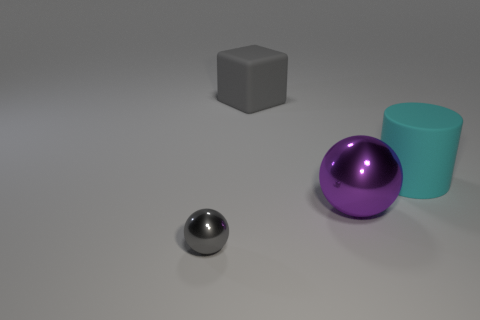Is there anything else that is the same size as the gray ball?
Offer a terse response. No. Does the large object that is left of the purple shiny object have the same color as the small ball?
Provide a succinct answer. Yes. There is a rubber thing that is the same color as the small metallic thing; what is its size?
Your answer should be very brief. Large. The matte object that is the same size as the cylinder is what color?
Make the answer very short. Gray. How many other metal objects are the same shape as the tiny metallic object?
Offer a terse response. 1. Is the material of the ball on the right side of the big gray cube the same as the gray sphere?
Keep it short and to the point. Yes. What number of blocks are either large gray objects or tiny matte things?
Ensure brevity in your answer.  1. There is a gray thing that is behind the ball that is left of the metallic object that is right of the small sphere; what shape is it?
Keep it short and to the point. Cube. What shape is the big rubber thing that is the same color as the tiny metal object?
Make the answer very short. Cube. What number of objects have the same size as the cylinder?
Your answer should be compact. 2. 